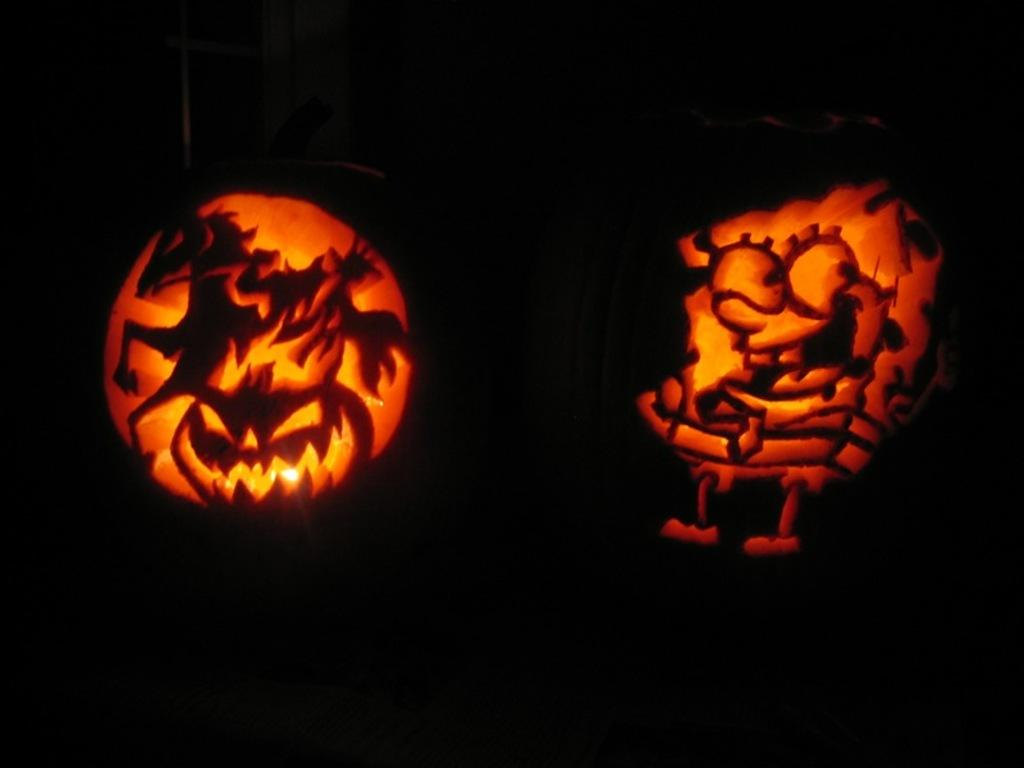What type of decorations can be seen in the image? There are carved pumpkins with lights in the image. How would you describe the lighting conditions in the image? The background of the image is dark. Can you identify any architectural features in the image? There is a window visible in the image. What type of stocking is hanging from the window in the image? There is no stocking hanging from the window in the image; only carved pumpkins with lights are present. 